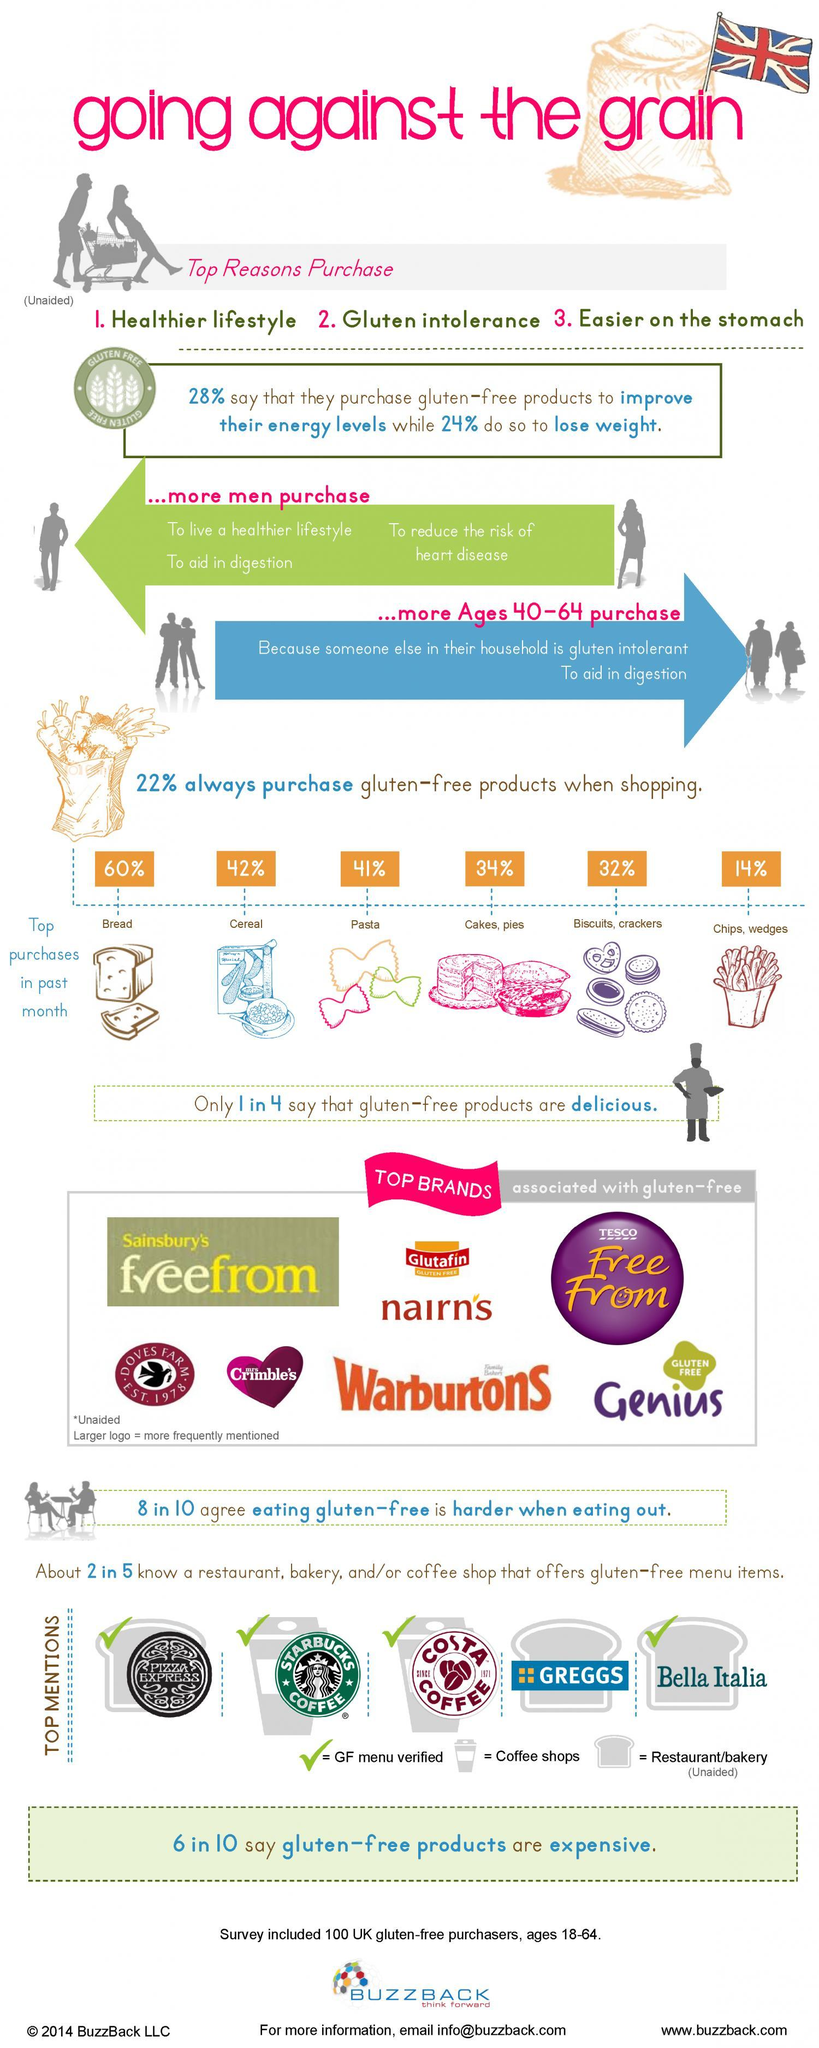Which is the second most gluten-free product purchased?
Answer the question with a short phrase. Cereal Which bakery or coffee shop does not have gluten free verified menu? Greggs Which two top brands have the same name for their gluten free products? Sainsbury's, Tesco Which brand is less frequently mentioned as being gluten-free? Glutafin 